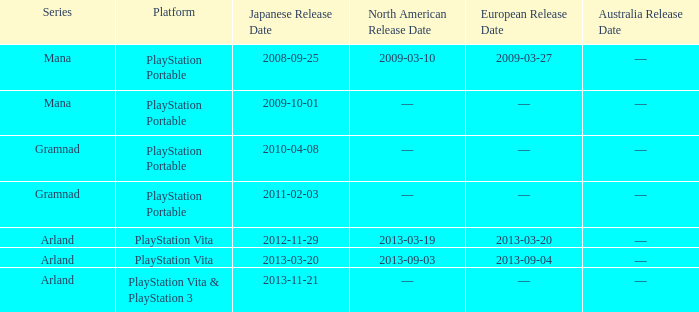What is the North American release date of the remake with a European release date on 2013-03-20? 2013-03-19. 